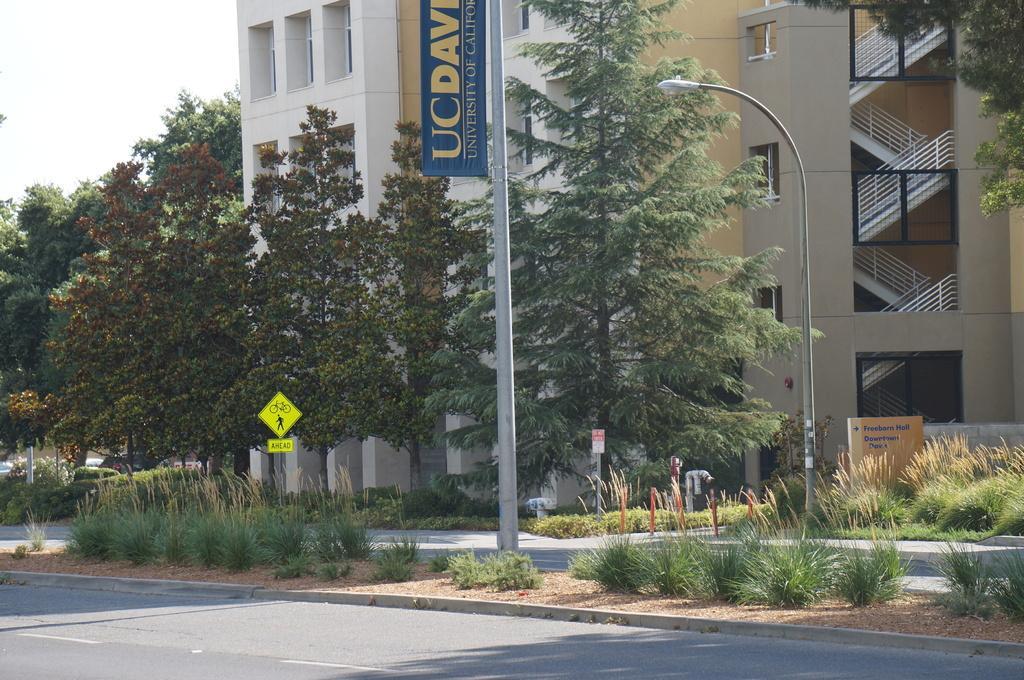Could you give a brief overview of what you see in this image? In this image there is a building, in front of the building there are trees, lamp posts, plants, sign boards, water pipes and roads. 